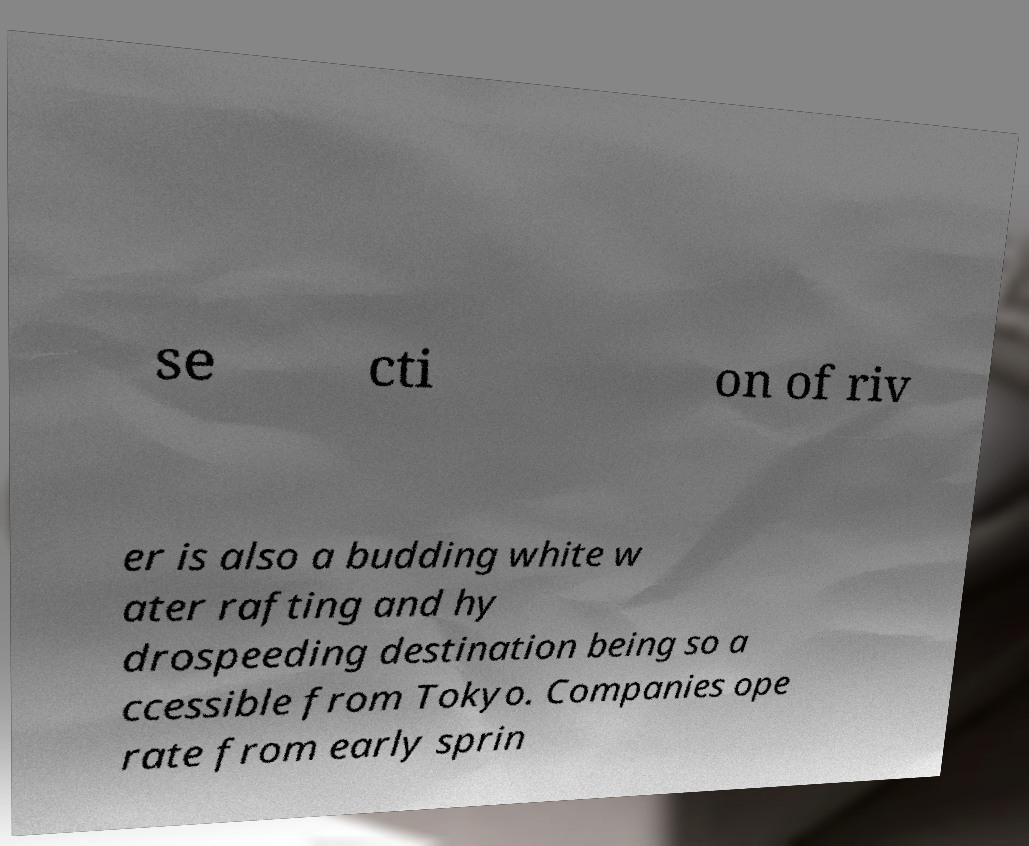Please identify and transcribe the text found in this image. se cti on of riv er is also a budding white w ater rafting and hy drospeeding destination being so a ccessible from Tokyo. Companies ope rate from early sprin 